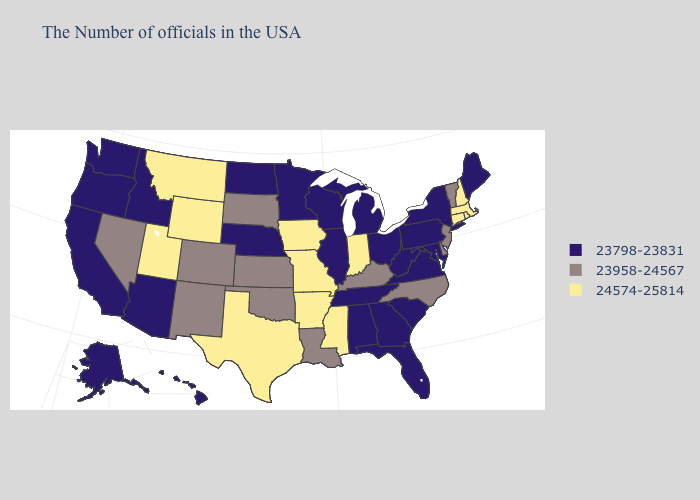Name the states that have a value in the range 23798-23831?
Short answer required. Maine, New York, Maryland, Pennsylvania, Virginia, South Carolina, West Virginia, Ohio, Florida, Georgia, Michigan, Alabama, Tennessee, Wisconsin, Illinois, Minnesota, Nebraska, North Dakota, Arizona, Idaho, California, Washington, Oregon, Alaska, Hawaii. Name the states that have a value in the range 23958-24567?
Quick response, please. Vermont, New Jersey, Delaware, North Carolina, Kentucky, Louisiana, Kansas, Oklahoma, South Dakota, Colorado, New Mexico, Nevada. Name the states that have a value in the range 24574-25814?
Quick response, please. Massachusetts, Rhode Island, New Hampshire, Connecticut, Indiana, Mississippi, Missouri, Arkansas, Iowa, Texas, Wyoming, Utah, Montana. Does Utah have a lower value than Minnesota?
Write a very short answer. No. What is the value of Minnesota?
Write a very short answer. 23798-23831. What is the value of South Carolina?
Be succinct. 23798-23831. Name the states that have a value in the range 23798-23831?
Give a very brief answer. Maine, New York, Maryland, Pennsylvania, Virginia, South Carolina, West Virginia, Ohio, Florida, Georgia, Michigan, Alabama, Tennessee, Wisconsin, Illinois, Minnesota, Nebraska, North Dakota, Arizona, Idaho, California, Washington, Oregon, Alaska, Hawaii. What is the value of North Dakota?
Concise answer only. 23798-23831. What is the highest value in the USA?
Be succinct. 24574-25814. Does the first symbol in the legend represent the smallest category?
Give a very brief answer. Yes. Does California have the highest value in the USA?
Concise answer only. No. Name the states that have a value in the range 23798-23831?
Short answer required. Maine, New York, Maryland, Pennsylvania, Virginia, South Carolina, West Virginia, Ohio, Florida, Georgia, Michigan, Alabama, Tennessee, Wisconsin, Illinois, Minnesota, Nebraska, North Dakota, Arizona, Idaho, California, Washington, Oregon, Alaska, Hawaii. What is the value of Arizona?
Keep it brief. 23798-23831. Does North Dakota have a lower value than Maryland?
Give a very brief answer. No. Does the map have missing data?
Write a very short answer. No. 